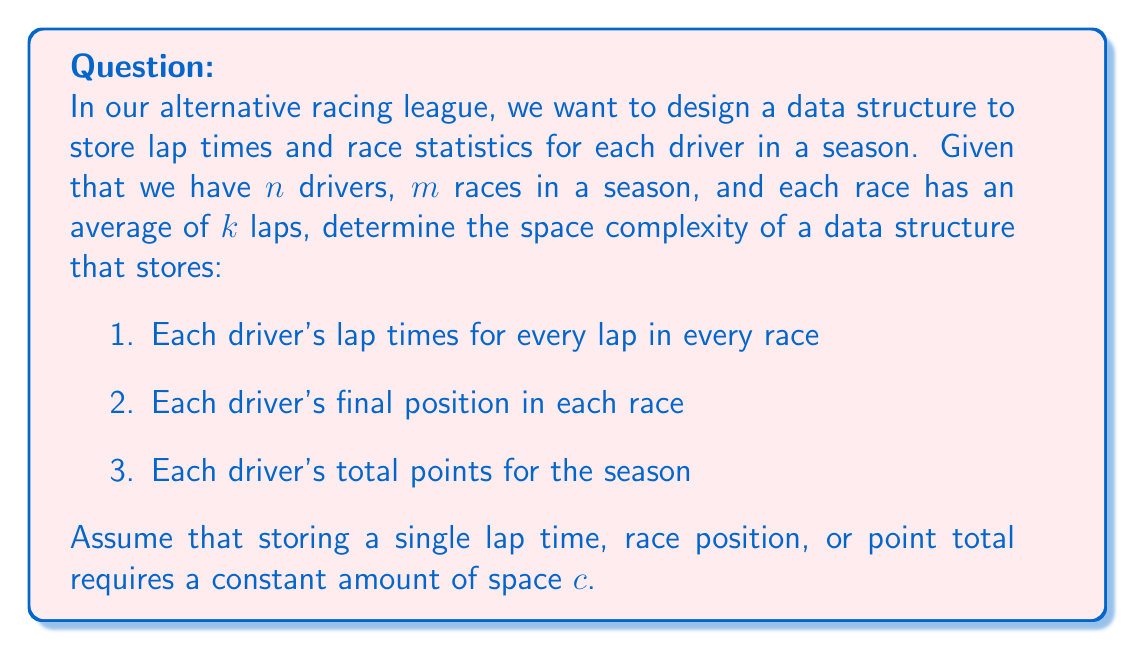Could you help me with this problem? Let's break this down step-by-step:

1. Storing lap times:
   - For each driver: $n$
   - For each race: $m$
   - For each lap: $k$
   - Space for each lap time: $c$
   Total space for lap times: $O(n \cdot m \cdot k \cdot c) = O(nmk)$

2. Storing final positions:
   - For each driver: $n$
   - For each race: $m$
   - Space for each position: $c$
   Total space for positions: $O(n \cdot m \cdot c) = O(nm)$

3. Storing total points:
   - For each driver: $n$
   - Space for each point total: $c$
   Total space for points: $O(n \cdot c) = O(n)$

To get the total space complexity, we sum up all these components:
$O(nmk) + O(nm) + O(n)$

Since $k$ (number of laps) is typically larger than 1, $O(nmk)$ dominates the other terms.

Therefore, the overall space complexity is $O(nmk)$.
Answer: $O(nmk)$ 